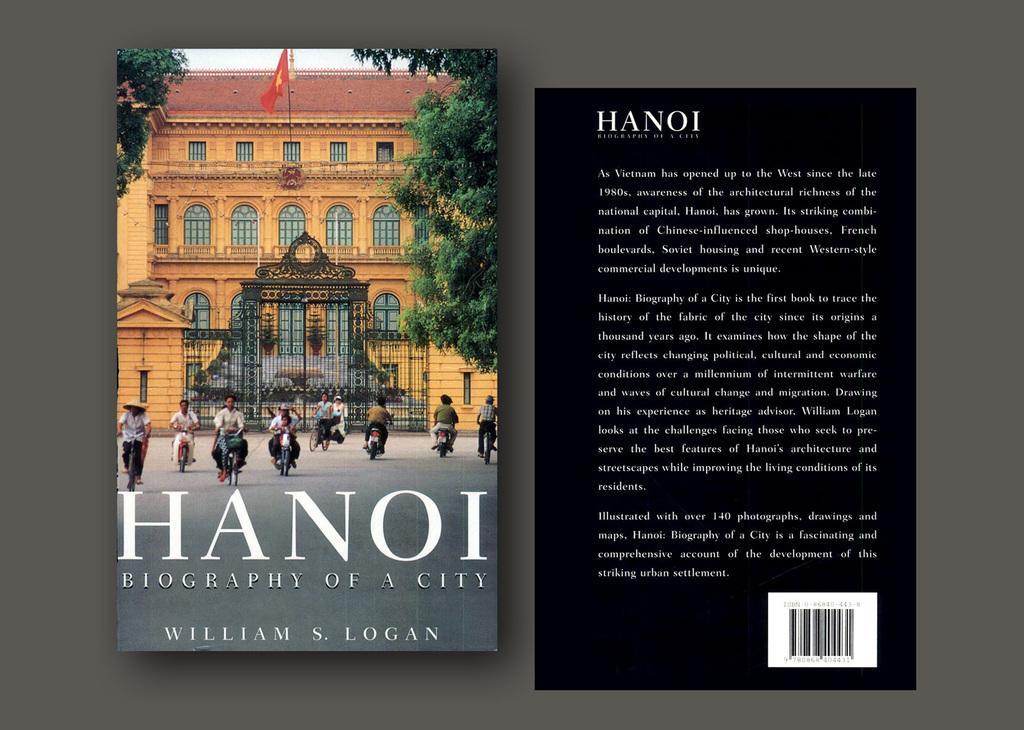Can you describe this image briefly? In this image we can see two posters, on the right side of the image there is a black poster with text and image. Left side poster there is one big building with black gate, one red flag with pole attached to the building, some text on the poster, some trees, some people riding bicycles and some people driving motorbikes on the road in front of the building. 